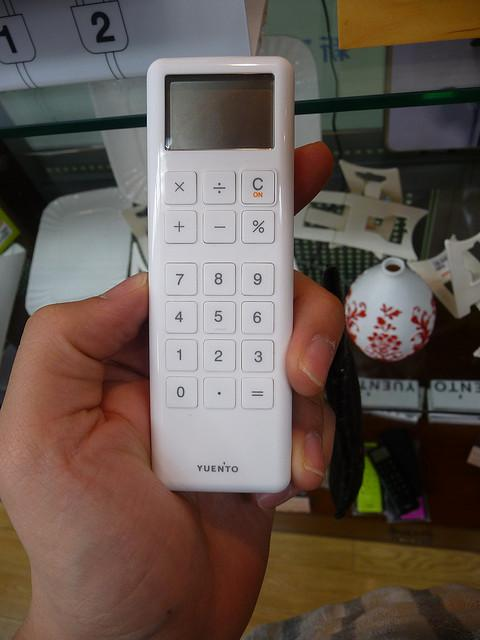What is this device used for? Please explain your reasoning. arithmetic. The remote has numbers and math symbols. 